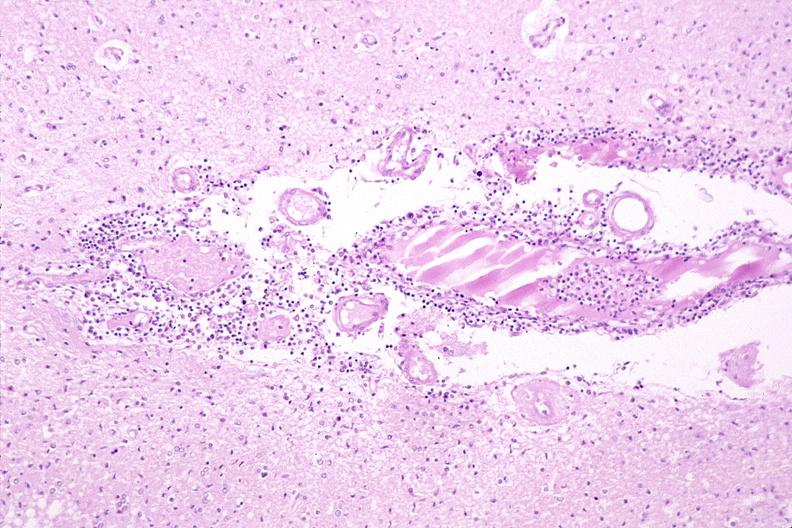what does this image show?
Answer the question using a single word or phrase. Brain 